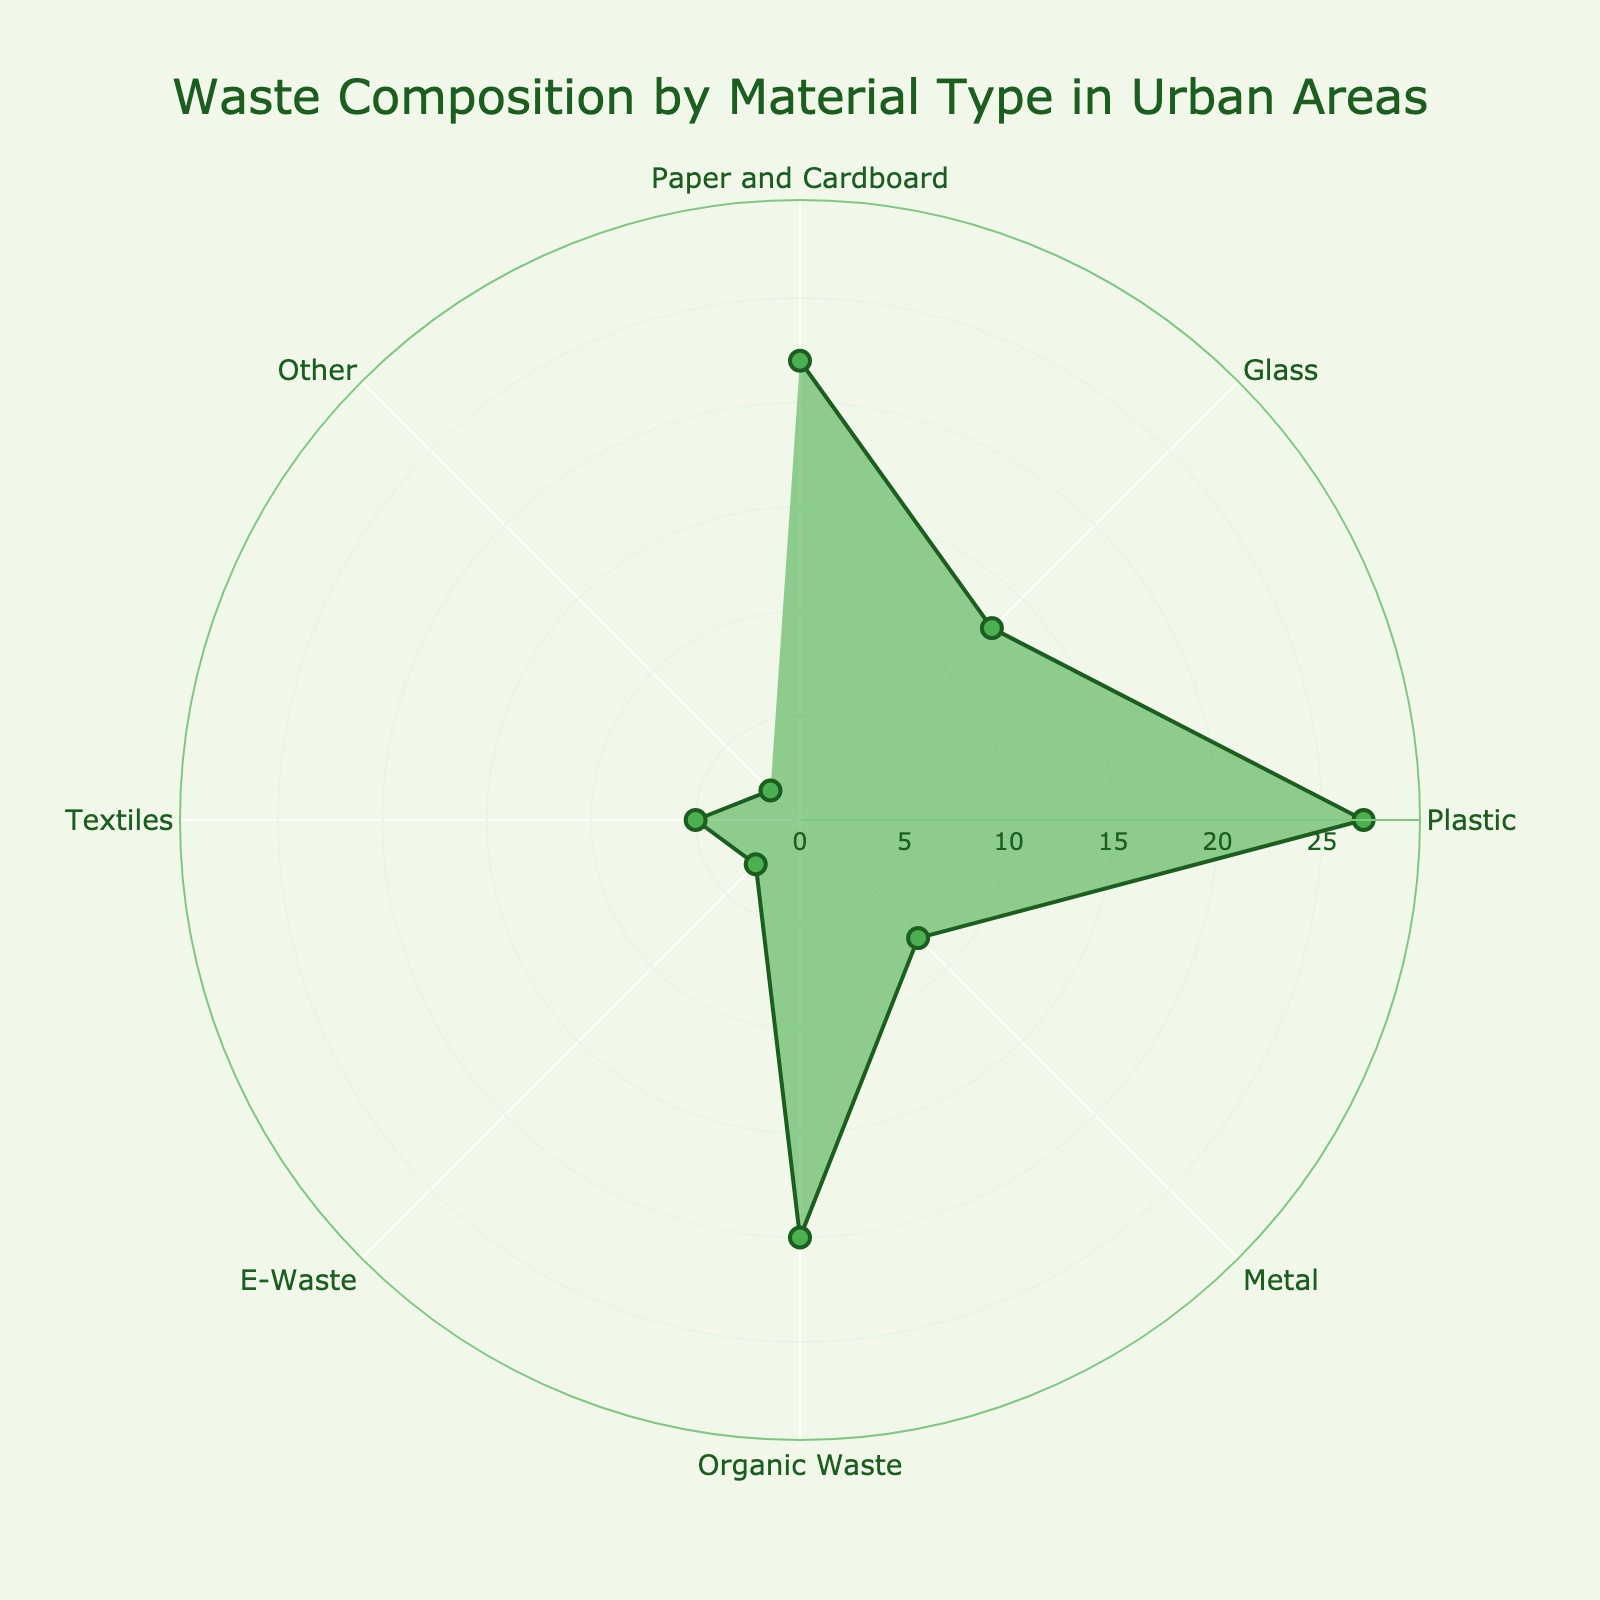Which material type has the highest percentage of composition in urban waste? The length of the radial line corresponding to each material indicates its percentage. The longest radial line is for Plastic.
Answer: Plastic What is the percentage composition of Organic Waste? Check the radial line corresponding to Organic Waste. The length of this line indicates its percentage.
Answer: 20% How much more Plastic is there compared to Metal in urban waste? Determine the percentage for both Plastic and Metal from their radial lines. Plastic is 27% and Metal is 8%. Subtract Metal's percentage from Plastic's.
Answer: 19% Which materials have a composition percentage below 10%? Identify the radial lines with lengths less than 10%. The materials with these lengths are Metal (8%), E-Waste (3%), Textiles (5%), and Other (2%).
Answer: Metal, E-Waste, Textiles, Other What is the total percentage of Paper and Cardboard, Glass, and Organic Waste combined? Add the percentages of Paper and Cardboard (22%), Glass (13%), and Organic Waste (20%). 22 + 13 + 20 = 55.
Answer: 55% Compare the percentage of E-Waste and Textiles in urban waste. Which is higher and by how much? Check the radial lines for E-Waste and Textiles. E-Waste is 3%, and Textiles is 5%. Textiles is higher by subtracting E-Waste's percentage from Textiles'.
Answer: Textiles by 2% How much does Other contribute to the total waste composition compared to Organic Waste? Identify the percentages for Other and Organic Waste. Other is 2%, and Organic Waste is 20%. Organic Waste is 20% - 2% = 18% more.
Answer: Organic Waste by 18% Which material types have radial lines between 5% and 15%? Identify radial lines in the range of 5% to 15%. The materials are Glass (13%) and Metal (8%).
Answer: Glass, Metal Is the sum of Plastic and E-Waste percentages greater than the sum of Paper and Cardboard and Glass? Sum the percentages: Plastic (27%) + E-Waste (3%) = 30%, Paper and Cardboard (22%) + Glass (13%) = 35%. Compare the two sums.
Answer: No What percentage of the total urban waste comes from Paper and Cardboard and Plastic combined? Add the percentages for Paper and Cardboard (22%) and Plastic (27%). 22 + 27 = 49.
Answer: 49% 